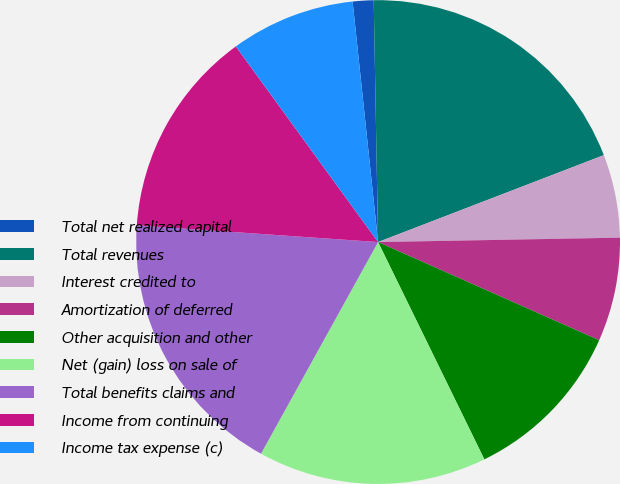Convert chart to OTSL. <chart><loc_0><loc_0><loc_500><loc_500><pie_chart><fcel>Total net realized capital<fcel>Total revenues<fcel>Interest credited to<fcel>Amortization of deferred<fcel>Other acquisition and other<fcel>Net (gain) loss on sale of<fcel>Total benefits claims and<fcel>Income from continuing<fcel>Income tax expense (c)<nl><fcel>1.39%<fcel>19.44%<fcel>5.56%<fcel>6.94%<fcel>11.11%<fcel>15.28%<fcel>18.06%<fcel>13.89%<fcel>8.33%<nl></chart> 